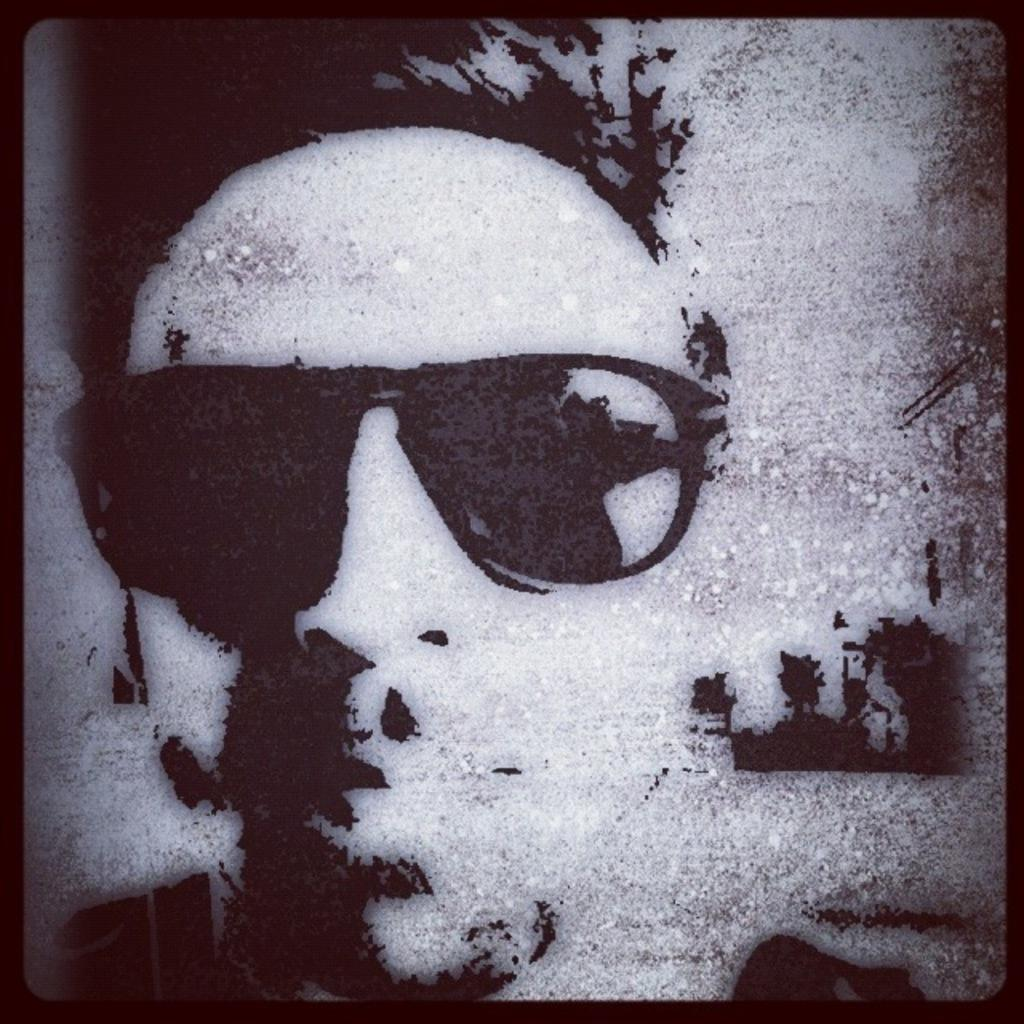What is the main subject of the image? There is an art piece in the image. What is depicted in the art piece? The art piece contains a person. What is the person wearing in the art piece? The person is wearing sunglasses. What type of behavior can be observed from the person in the bedroom in the image? There is no bedroom present in the image, and the person's behavior cannot be determined from the art piece alone. 